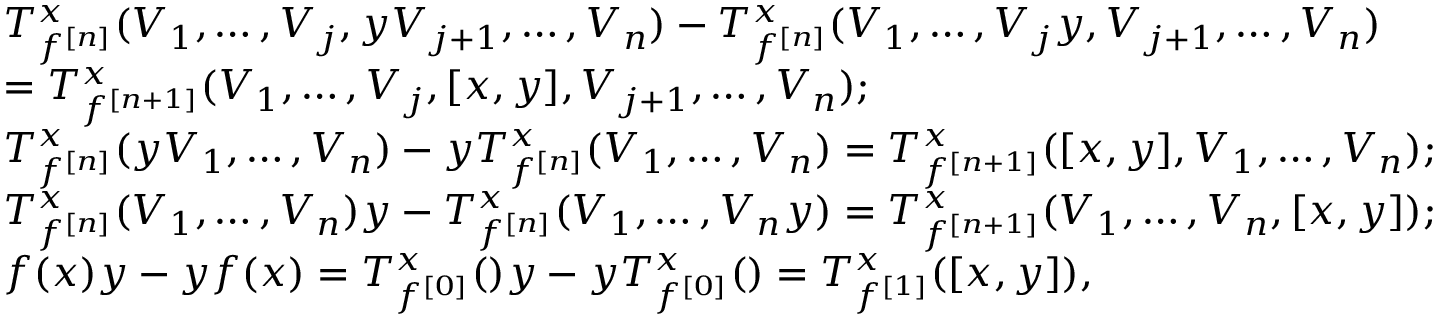<formula> <loc_0><loc_0><loc_500><loc_500>\begin{array} { r l } & { T _ { f ^ { [ n ] } } ^ { x } ( V _ { 1 } , \dots , V _ { j } , y V _ { j + 1 } , \dots , V _ { n } ) - T _ { f ^ { [ n ] } } ^ { x } ( V _ { 1 } , \dots , V _ { j } y , V _ { j + 1 } , \dots , V _ { n } ) } \\ & { = T _ { f ^ { [ n + 1 ] } } ^ { x } ( V _ { 1 } , \dots , V _ { j } , [ x , y ] , V _ { j + 1 } , \dots , V _ { n } ) ; } \\ & { T _ { f ^ { [ n ] } } ^ { x } ( y V _ { 1 } , \dots , V _ { n } ) - y T _ { f ^ { [ n ] } } ^ { x } ( V _ { 1 } , \dots , V _ { n } ) = T _ { f ^ { [ n + 1 ] } } ^ { x } ( [ x , y ] , V _ { 1 } , \dots , V _ { n } ) ; } \\ & { T _ { f ^ { [ n ] } } ^ { x } ( V _ { 1 } , \dots , V _ { n } ) y - T _ { f ^ { [ n ] } } ^ { x } ( V _ { 1 } , \dots , V _ { n } y ) = T _ { f ^ { [ n + 1 ] } } ^ { x } ( V _ { 1 } , \dots , V _ { n } , [ x , y ] ) ; } \\ & { f ( x ) y - y f ( x ) = T _ { f ^ { [ 0 ] } } ^ { x } ( ) y - y T _ { f ^ { [ 0 ] } } ^ { x } ( ) = T _ { f ^ { [ 1 ] } } ^ { x } ( [ x , y ] ) , } \end{array}</formula> 